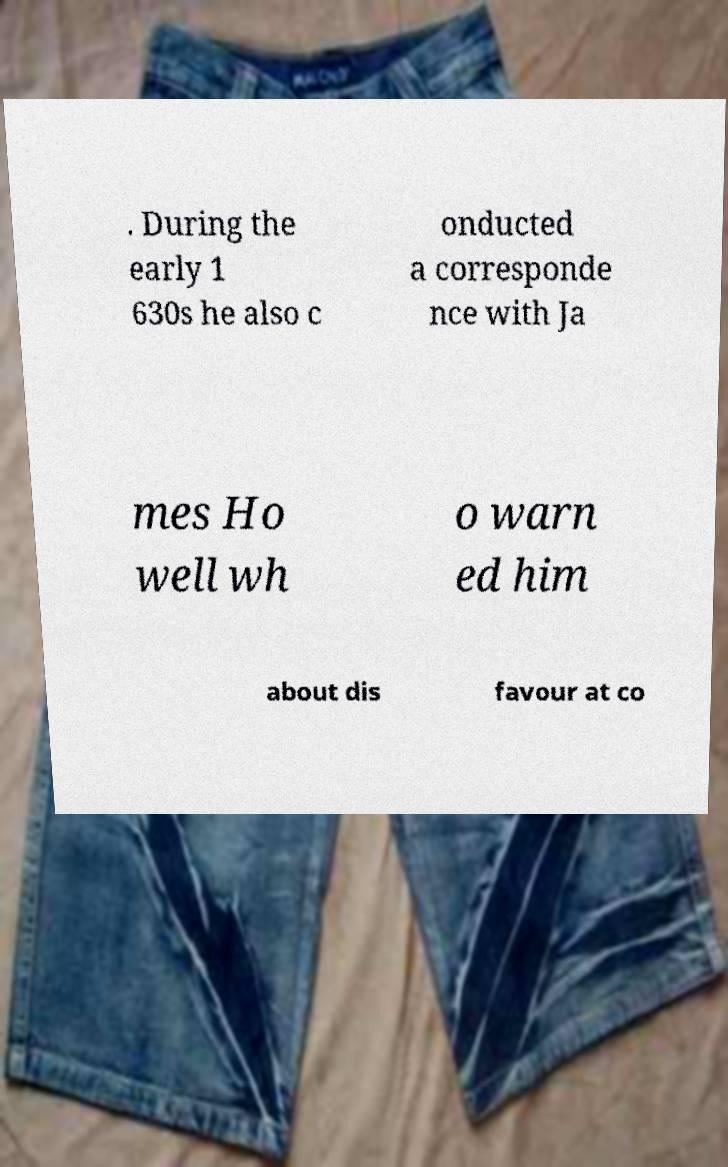For documentation purposes, I need the text within this image transcribed. Could you provide that? . During the early 1 630s he also c onducted a corresponde nce with Ja mes Ho well wh o warn ed him about dis favour at co 